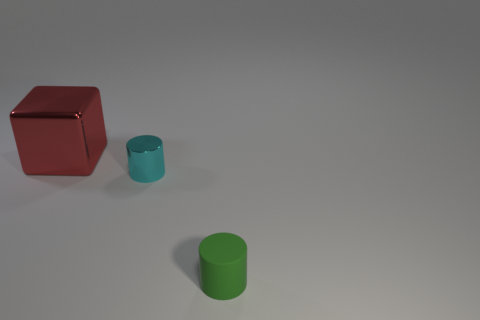Add 2 red metal blocks. How many objects exist? 5 Subtract all cubes. How many objects are left? 2 Add 2 cyan objects. How many cyan objects are left? 3 Add 2 big cyan shiny things. How many big cyan shiny things exist? 2 Subtract 1 green cylinders. How many objects are left? 2 Subtract all gray rubber blocks. Subtract all small cyan cylinders. How many objects are left? 2 